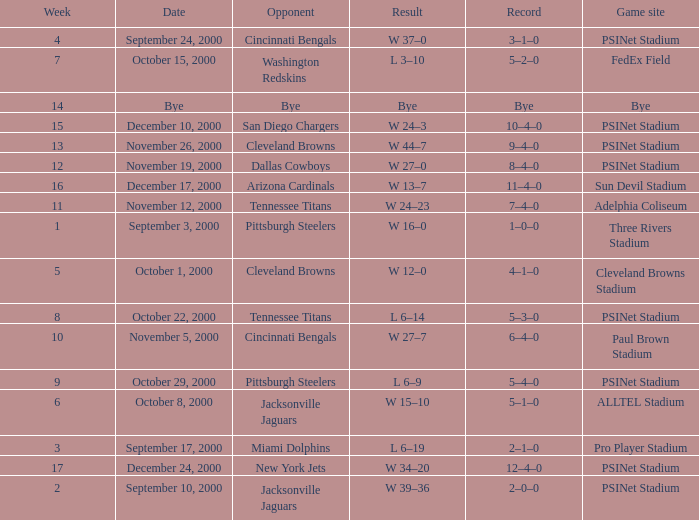What's the record after week 16? 12–4–0. 